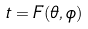Convert formula to latex. <formula><loc_0><loc_0><loc_500><loc_500>t = F ( \theta , \phi )</formula> 